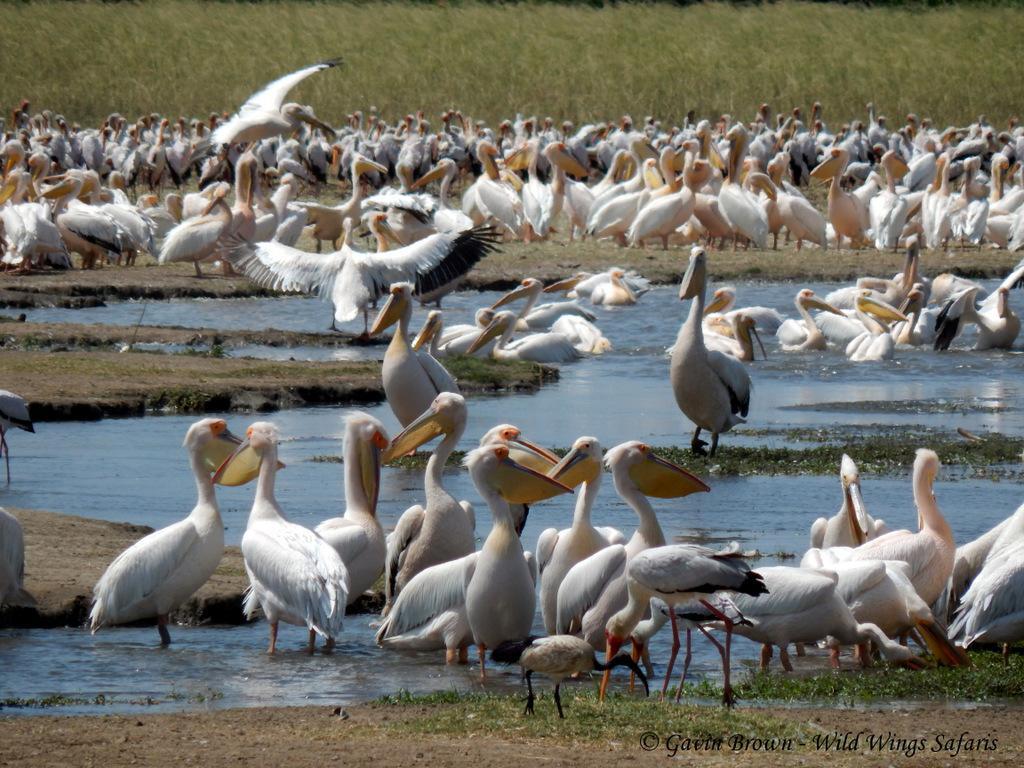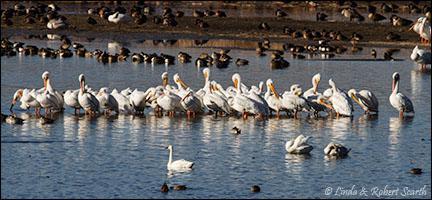The first image is the image on the left, the second image is the image on the right. Evaluate the accuracy of this statement regarding the images: "A few of the birds are in the air in one one the images.". Is it true? Answer yes or no. Yes. The first image is the image on the left, the second image is the image on the right. For the images shown, is this caption "In one image, nearly all pelicans in the foreground face leftward." true? Answer yes or no. No. 